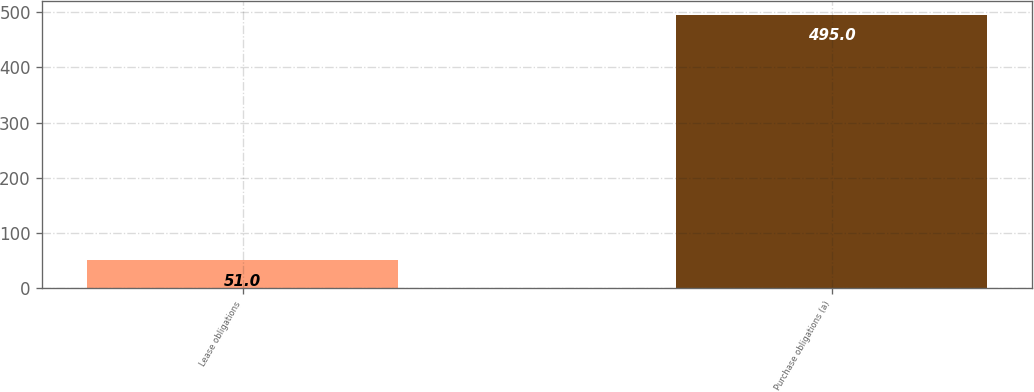<chart> <loc_0><loc_0><loc_500><loc_500><bar_chart><fcel>Lease obligations<fcel>Purchase obligations (a)<nl><fcel>51<fcel>495<nl></chart> 